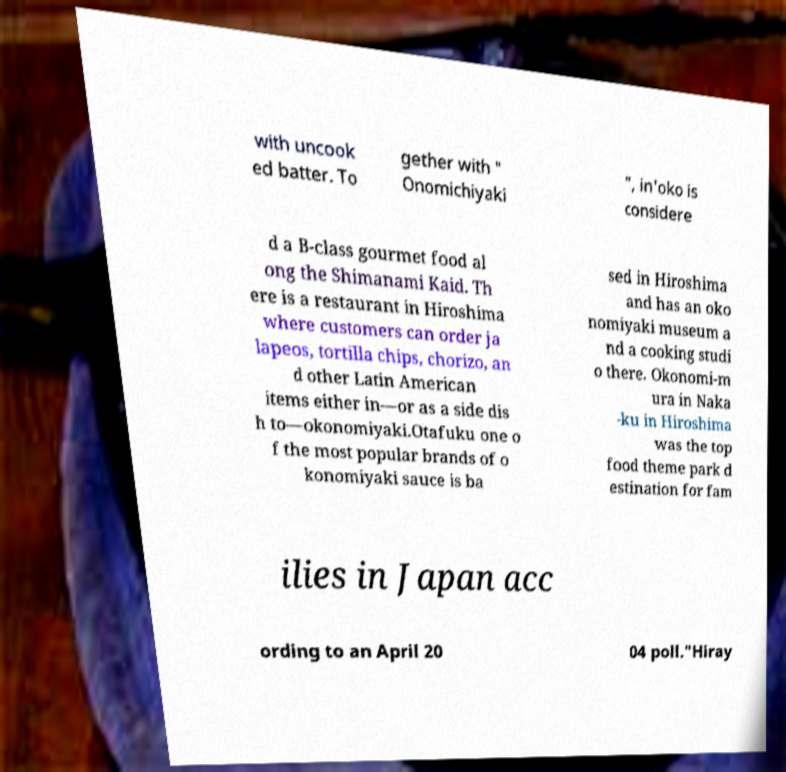For documentation purposes, I need the text within this image transcribed. Could you provide that? with uncook ed batter. To gether with " Onomichiyaki ", in'oko is considere d a B-class gourmet food al ong the Shimanami Kaid. Th ere is a restaurant in Hiroshima where customers can order ja lapeos, tortilla chips, chorizo, an d other Latin American items either in—or as a side dis h to—okonomiyaki.Otafuku one o f the most popular brands of o konomiyaki sauce is ba sed in Hiroshima and has an oko nomiyaki museum a nd a cooking studi o there. Okonomi-m ura in Naka -ku in Hiroshima was the top food theme park d estination for fam ilies in Japan acc ording to an April 20 04 poll."Hiray 